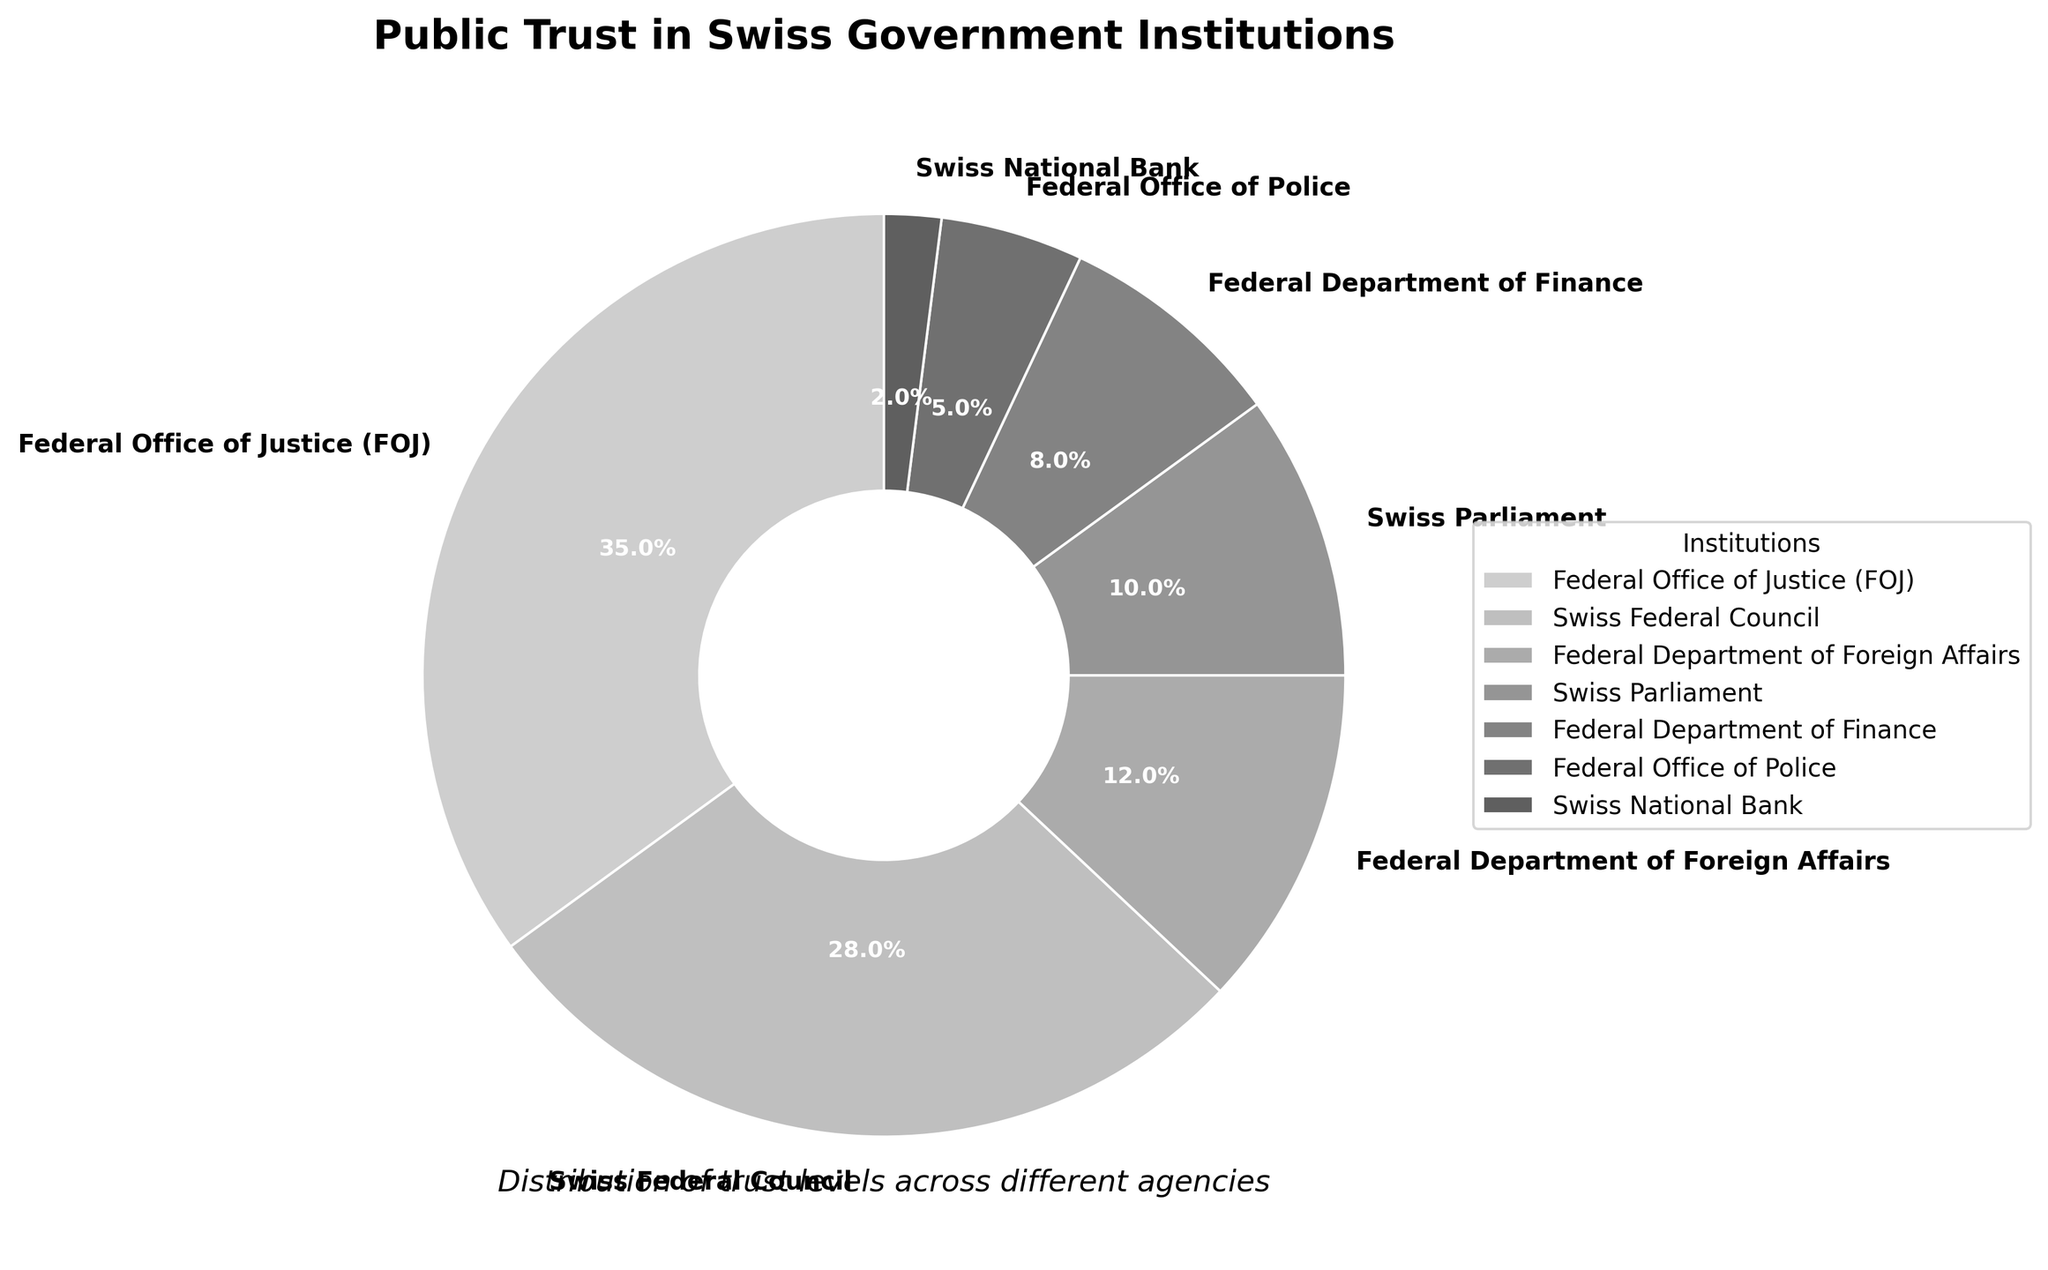How many institutions have a trust level greater than 10%? Identify the trust levels for each institution: FOJ (35%), Swiss Federal Council (28%), and Federal Department of Foreign Affairs (12%). Count the institutions meeting the criteria. 3 institutions have trust levels greater than 10%.
Answer: 3 Which institution has the highest trust level, and what is it? Locate the institution with the maximum trust level among the values provided: FOJ at 35%.
Answer: Federal Office of Justice (FOJ) with 35% Compare the trust levels of the Swiss Parliament and the Federal Department of Finance. Which one is higher? Swiss Parliament has a trust level of 10%, while the Federal Department of Finance has 8%. Since 10% is greater than 8%, the Swiss Parliament has a higher trust level.
Answer: Swiss Parliament (10%) What is the combined trust level of the Swiss Federal Council and the Federal Office of Justice? Add the trust levels of both institutions: 28% (Swiss Federal Council) + 35% (FOJ) = 63%.
Answer: 63% Calculate the average trust level across all institutions listed. Sum the trust levels of all institutions: 35 + 28 + 12 + 10 + 8 + 5 + 2 = 100. Divide by the number of institutions (7): 100 / 7 ≈ 14.3%.
Answer: 14.3% Which institution has the lowest trust level? Locate the institution with the minimum trust level: Swiss National Bank with 2%.
Answer: Swiss National Bank Is the combined trust level of the Federal Department of Foreign Affairs and the Federal Department of Finance greater than the trust level of the Swiss Federal Council? Add trust levels for the Federal Department of Foreign Affairs (12%) and the Federal Department of Finance (8%): 12 + 8 = 20%. Compare with the Swiss Federal Council's 28%. 20% is less than 28%.
Answer: No By how much does the trust level of the FOJ exceed that of the Federal Department of Foreign Affairs? Subtract the trust level of the Federal Department of Foreign Affairs from FOJ's trust level: 35% - 12% = 23%.
Answer: 23% What percentage of the total trust level do the Federal Office of Police and the Swiss National Bank account for? Add the trust levels of the Federal Office of Police (5%) and the Swiss National Bank (2%): 5 + 2 = 7%.
Answer: 7% List the institutions in descending order of their trust levels. Order the institutions from highest to lowest based on their trust levels: FOJ (35%), Swiss Federal Council (28%), Federal Department of Foreign Affairs (12%), Swiss Parliament (10%), Federal Department of Finance (8%), Federal Office of Police (5%), and Swiss National Bank (2%).
Answer: FOJ, Swiss Federal Council, Federal Department of Foreign Affairs, Swiss Parliament, Federal Department of Finance, Federal Office of Police, Swiss National Bank 